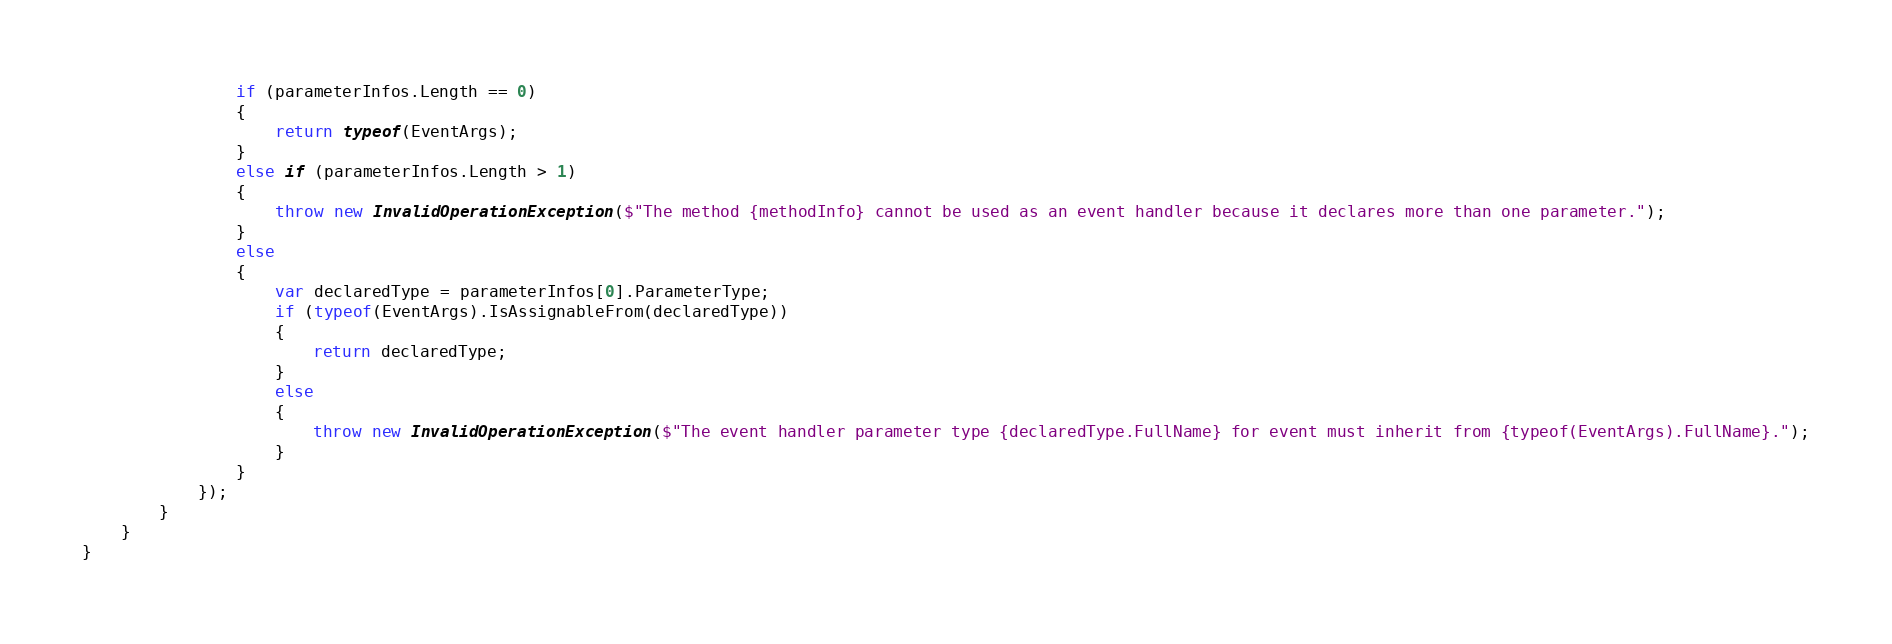<code> <loc_0><loc_0><loc_500><loc_500><_C#_>                if (parameterInfos.Length == 0)
                {
                    return typeof(EventArgs);
                }
                else if (parameterInfos.Length > 1)
                {
                    throw new InvalidOperationException($"The method {methodInfo} cannot be used as an event handler because it declares more than one parameter.");
                }
                else
                {
                    var declaredType = parameterInfos[0].ParameterType;
                    if (typeof(EventArgs).IsAssignableFrom(declaredType))
                    {
                        return declaredType;
                    }
                    else
                    {
                        throw new InvalidOperationException($"The event handler parameter type {declaredType.FullName} for event must inherit from {typeof(EventArgs).FullName}.");
                    }
                }
            });
        }
    }
}
</code> 